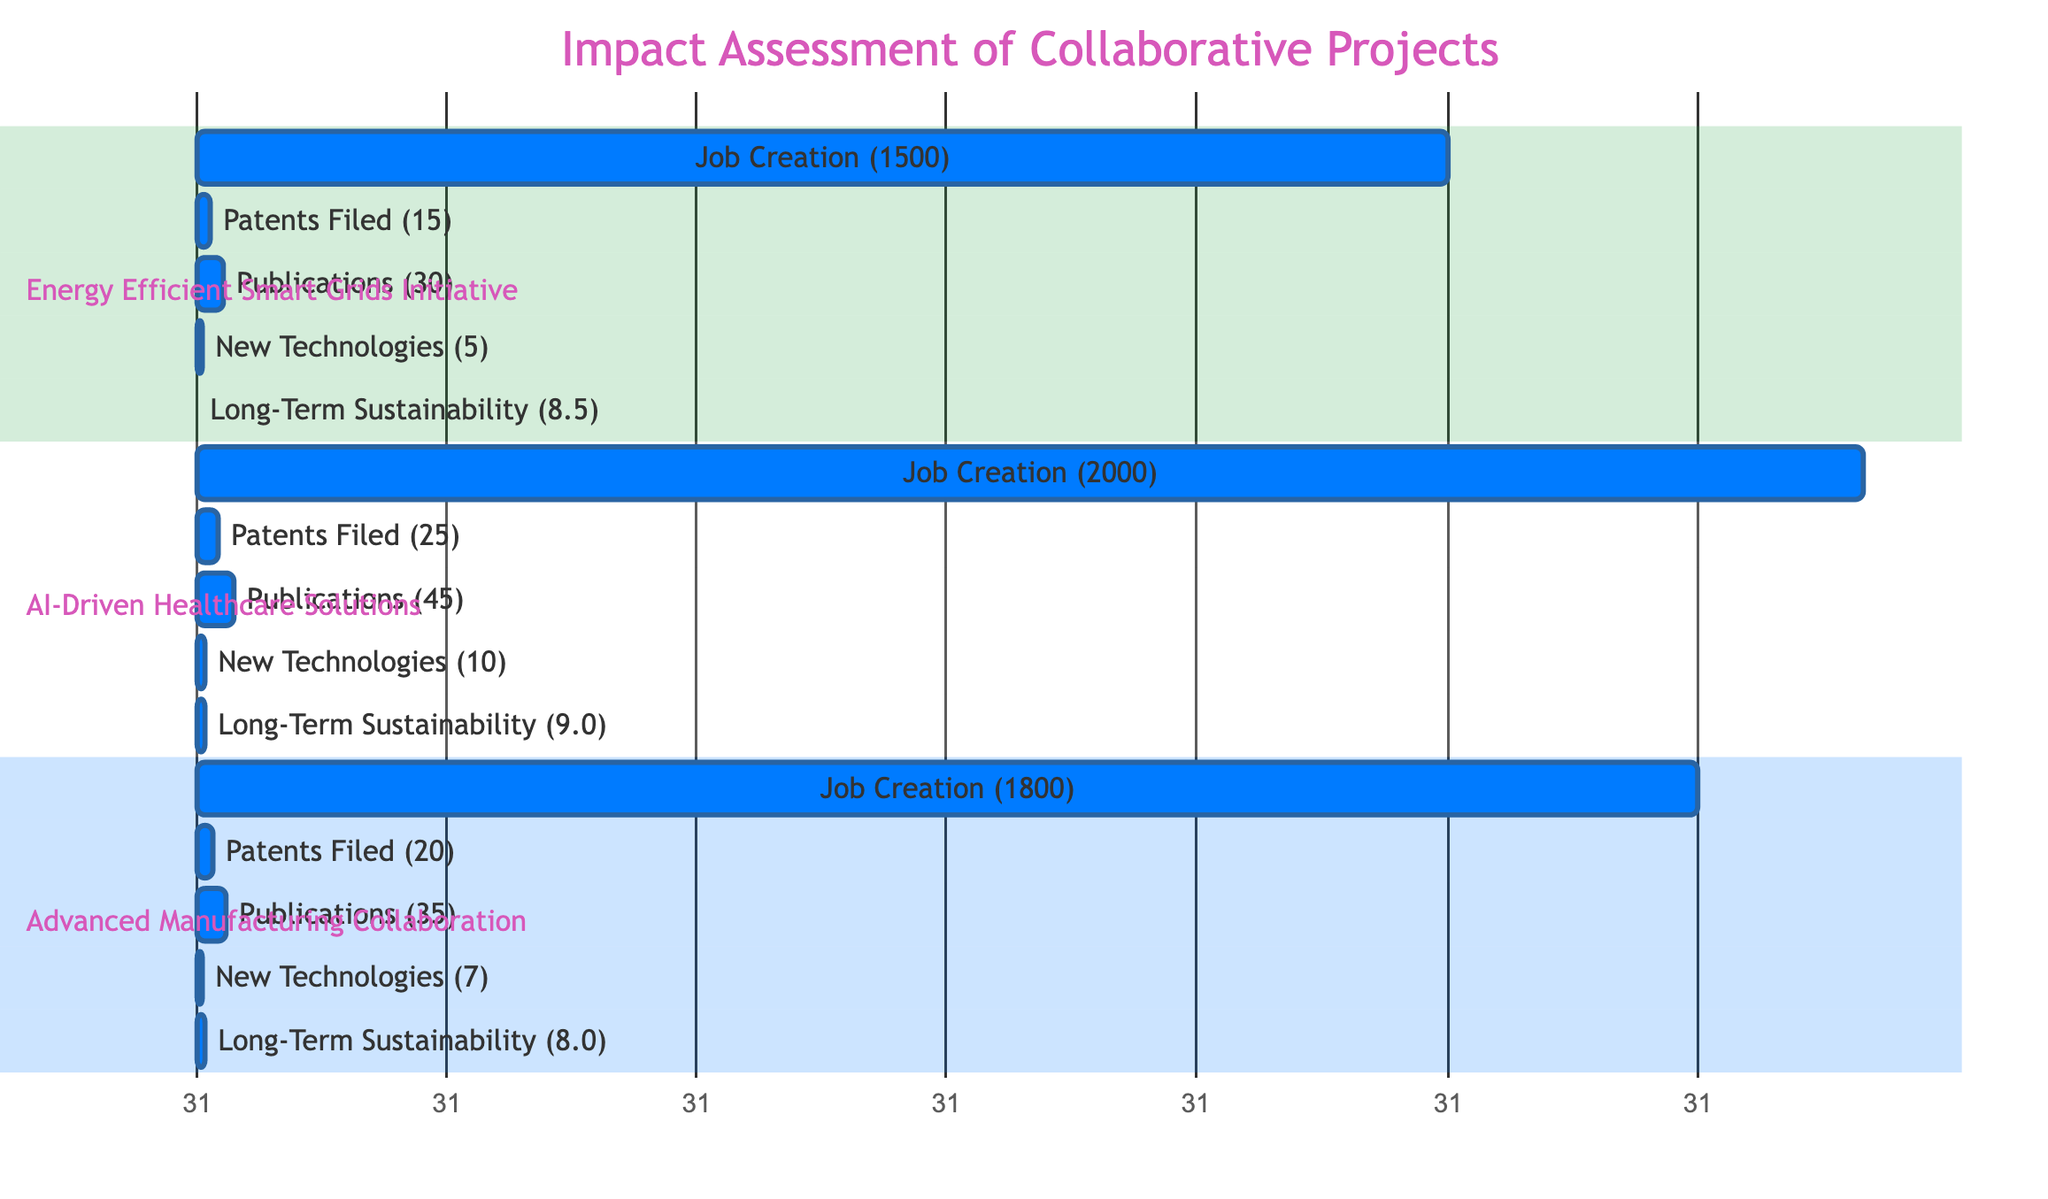What is the job creation number for the AI-Driven Healthcare Solutions project? The diagram shows a section for the AI-Driven Healthcare Solutions project where the job creation metric is listed as 2000.
Answer: 2000 What is the total number of patents filed across all projects? To find the total number of patents filed, we need to sum the patents from each project: 15 (Energy Efficient Smart Grids Initiative) + 25 (AI-Driven Healthcare Solutions) + 20 (Advanced Manufacturing Collaboration) = 60.
Answer: 60 Which project has the highest number of publications? By comparing the publication numbers in each section, we see that the AI-Driven Healthcare Solutions project has the highest number at 45.
Answer: AI-Driven Healthcare Solutions What is the long-term sustainability rating for the Advanced Manufacturing Collaboration? The Advanced Manufacturing Collaboration section shows a long-term sustainability rating of 8.0.
Answer: 8.0 How many new technologies were developed in total across all projects? To calculate the total new technologies developed, we add the numbers from each project: 5 (Energy Efficient Smart Grids Initiative) + 10 (AI-Driven Healthcare Solutions) + 7 (Advanced Manufacturing Collaboration) = 22.
Answer: 22 Which project resulted in the least job creation? Looking at the job creation figures, the Energy Efficient Smart Grids Initiative has the lowest number at 1500.
Answer: Energy Efficient Smart Grids Initiative How does the job creation of the Energy Efficient Smart Grids Initiative compare to that of Advanced Manufacturing Collaboration? The job creation for the Energy Efficient Smart Grids Initiative is 1500, while the Advanced Manufacturing Collaboration is 1800. Thus, the Advanced Manufacturing Collaboration has 300 more jobs created than the Energy Efficient Smart Grids Initiative.
Answer: 300 What is the difference in long-term sustainability between AI-Driven Healthcare Solutions and Advanced Manufacturing Collaboration? The long-term sustainability rating for AI-Driven Healthcare Solutions is 9.0, while for Advanced Manufacturing Collaboration, it is 8.0. The difference is 1.0.
Answer: 1.0 Which project has the highest score in patents filed? The project with the highest score in patents filed is AI-Driven Healthcare Solutions with 25 patents.
Answer: AI-Driven Healthcare Solutions 